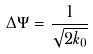<formula> <loc_0><loc_0><loc_500><loc_500>\Delta \Psi = { \frac { 1 } { \sqrt { 2 k _ { 0 } } } }</formula> 